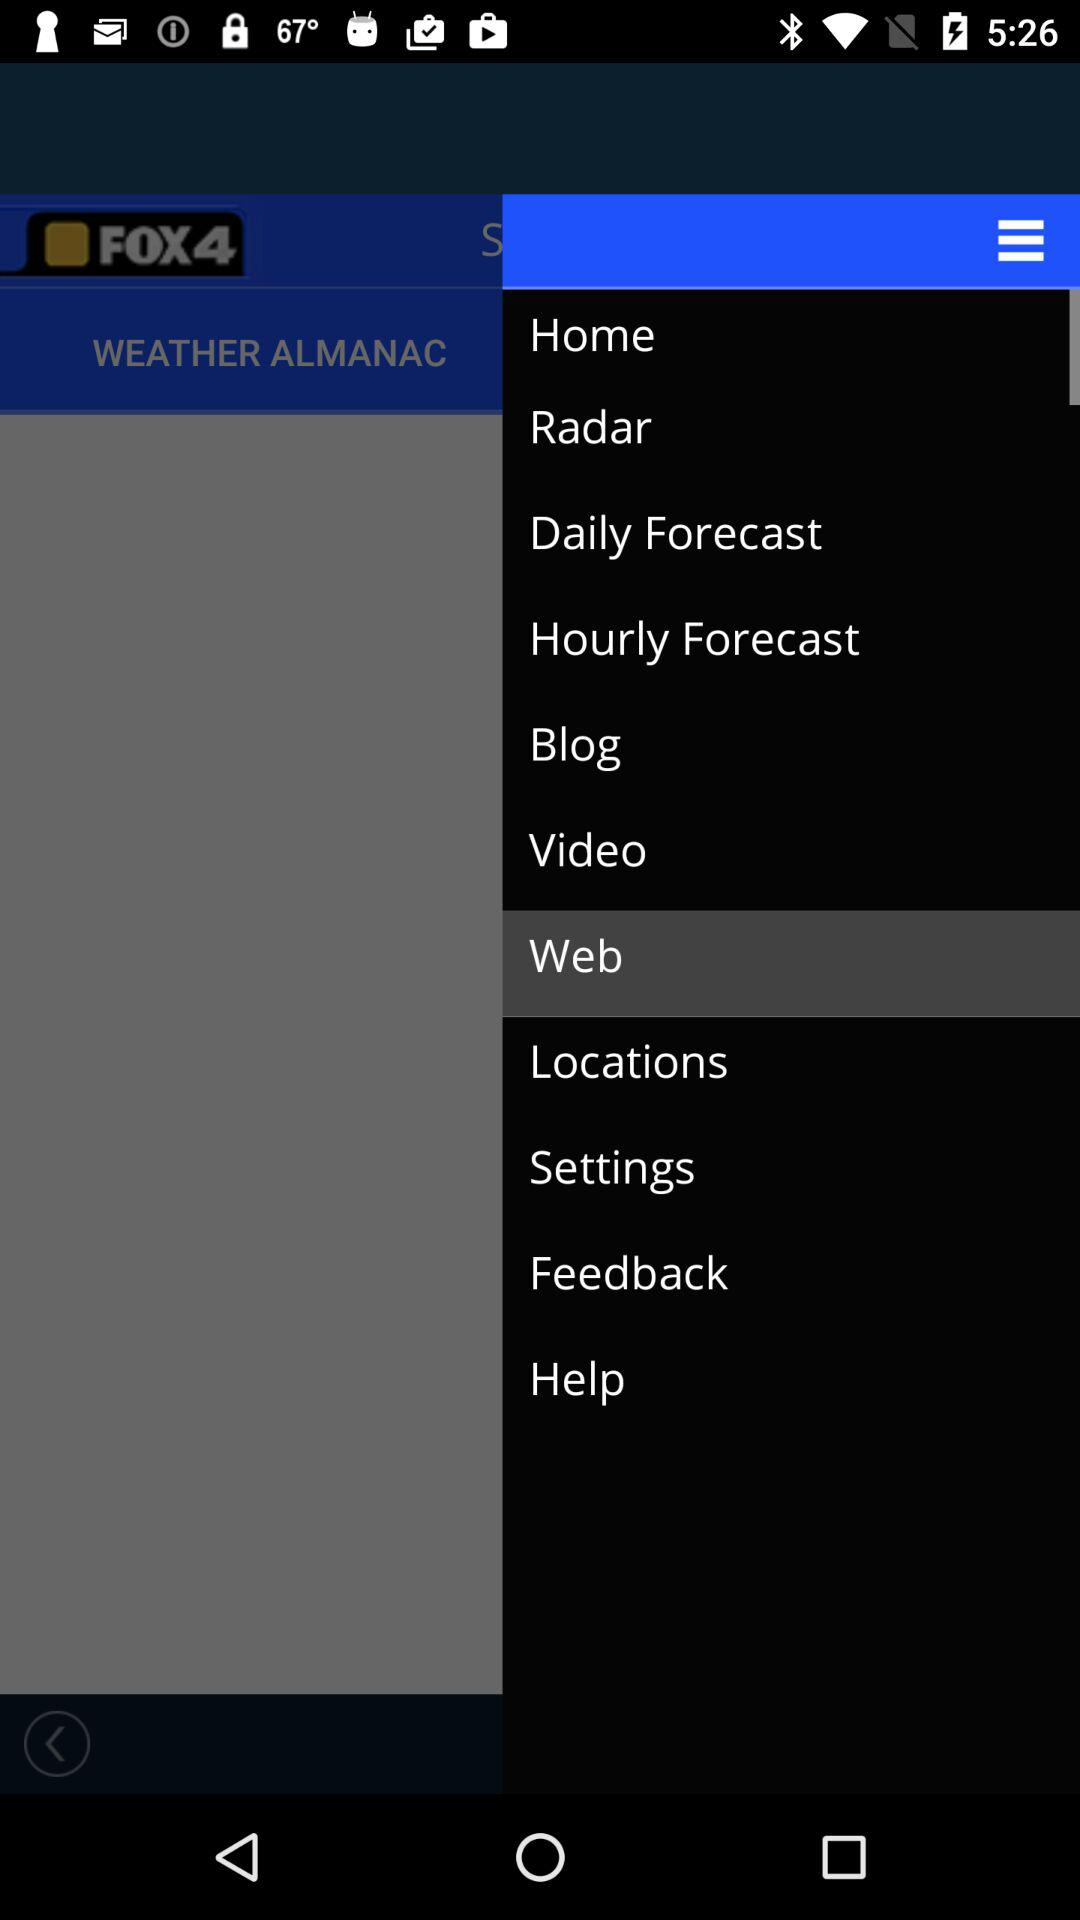What is the app name? The app name is "FOX4". 